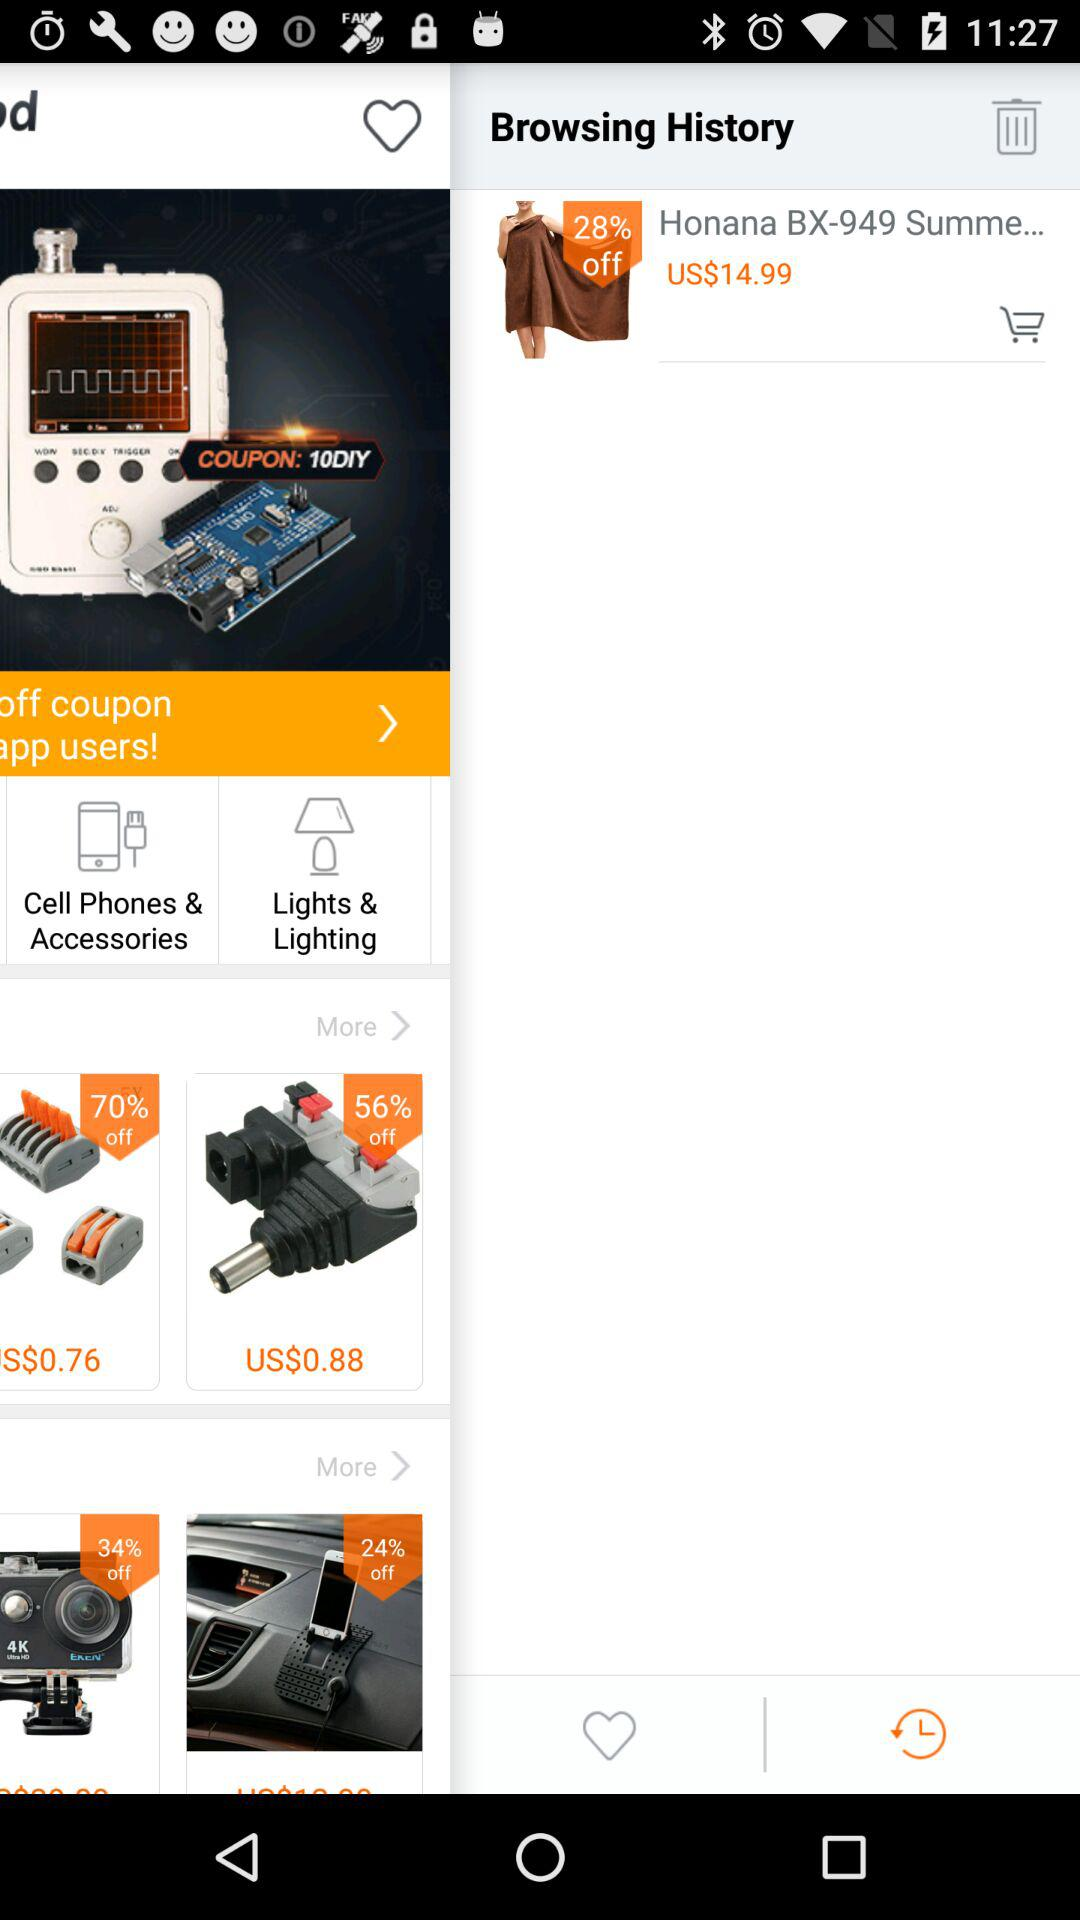How much is the discount on honana? The discount is 28% off. 